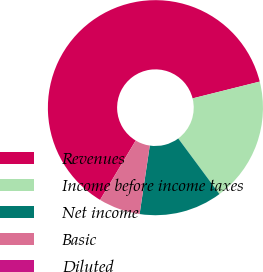<chart> <loc_0><loc_0><loc_500><loc_500><pie_chart><fcel>Revenues<fcel>Income before income taxes<fcel>Net income<fcel>Basic<fcel>Diluted<nl><fcel>62.5%<fcel>18.75%<fcel>12.5%<fcel>6.25%<fcel>0.0%<nl></chart> 